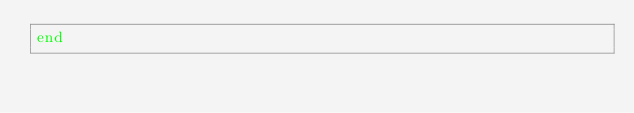Convert code to text. <code><loc_0><loc_0><loc_500><loc_500><_Crystal_>end

</code> 